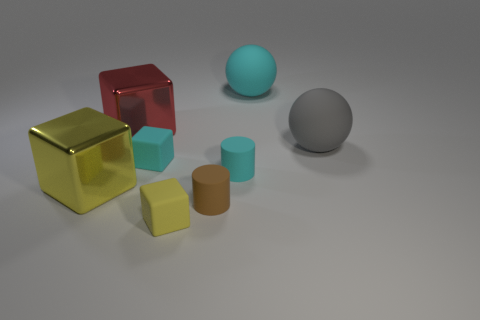The red shiny object that is on the left side of the large gray sphere has what shape? The red shiny object on the left side of the large gray sphere is not a cube; it actually has a spherical shape, similar to how a ball looks. Its surface reflects light, creating a glossy appearance. 